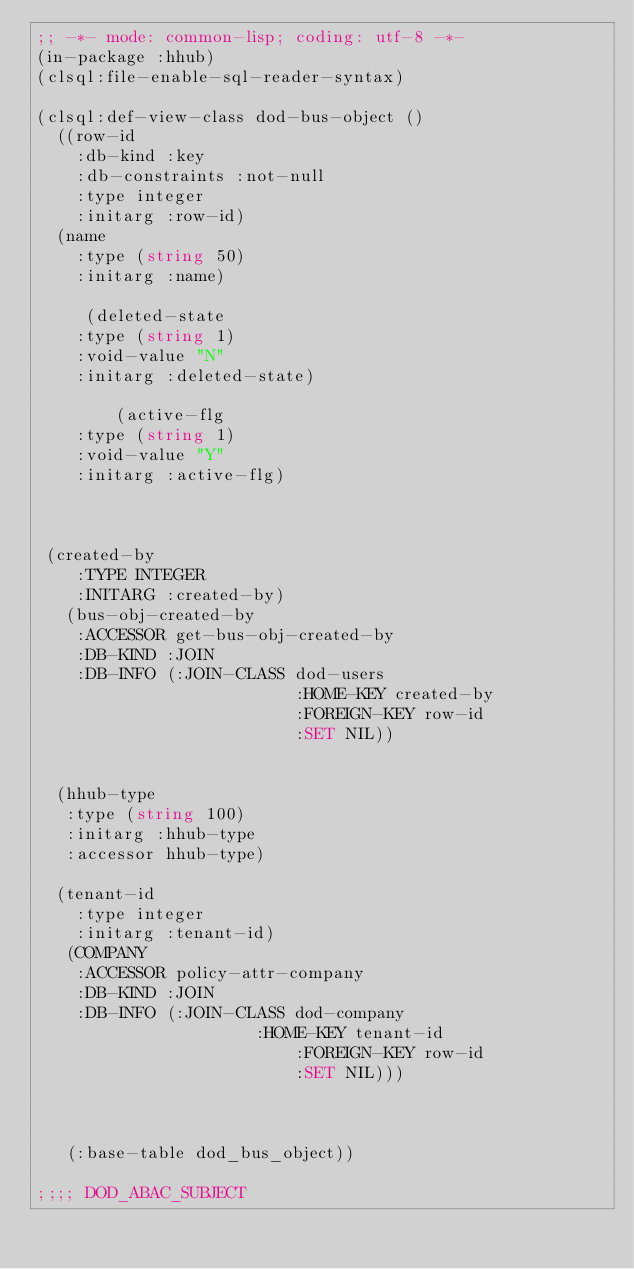Convert code to text. <code><loc_0><loc_0><loc_500><loc_500><_Lisp_>;; -*- mode: common-lisp; coding: utf-8 -*-
(in-package :hhub)
(clsql:file-enable-sql-reader-syntax)

(clsql:def-view-class dod-bus-object ()
  ((row-id
    :db-kind :key
    :db-constraints :not-null
    :type integer
    :initarg :row-id)
  (name
    :type (string 50)
    :initarg :name)

     (deleted-state
    :type (string 1)
    :void-value "N"
    :initarg :deleted-state)

        (active-flg
    :type (string 1)
    :void-value "Y"
    :initarg :active-flg)


   
 (created-by
    :TYPE INTEGER
    :INITARG :created-by)
   (bus-obj-created-by
    :ACCESSOR get-bus-obj-created-by
    :DB-KIND :JOIN
    :DB-INFO (:JOIN-CLASS dod-users
                          :HOME-KEY created-by
                          :FOREIGN-KEY row-id
                          :SET NIL))
 
  
  (hhub-type
   :type (string 100)
   :initarg :hhub-type
   :accessor hhub-type)
  
  (tenant-id
    :type integer
    :initarg :tenant-id)
   (COMPANY
    :ACCESSOR policy-attr-company
    :DB-KIND :JOIN
    :DB-INFO (:JOIN-CLASS dod-company
	                  :HOME-KEY tenant-id
                          :FOREIGN-KEY row-id
                          :SET NIL)))



   (:base-table dod_bus_object))

;;;; DOD_ABAC_SUBJECT
</code> 